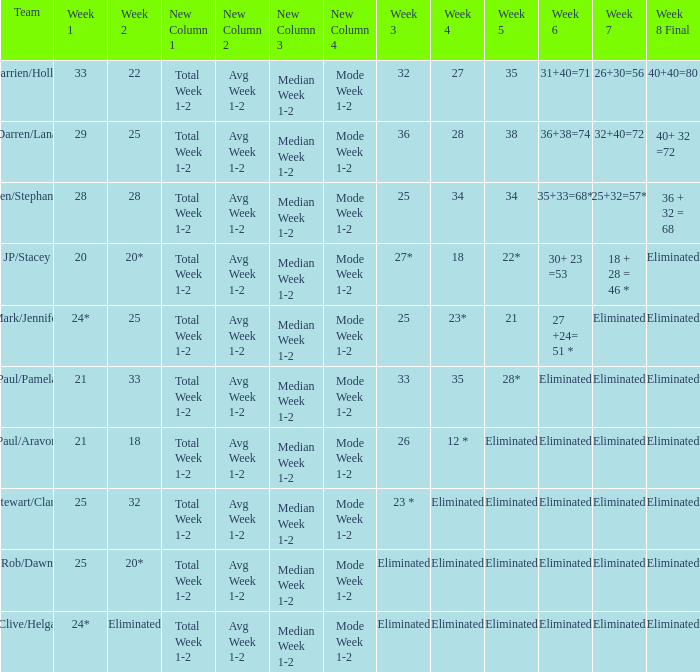Name the week 3 of 36 29.0. 